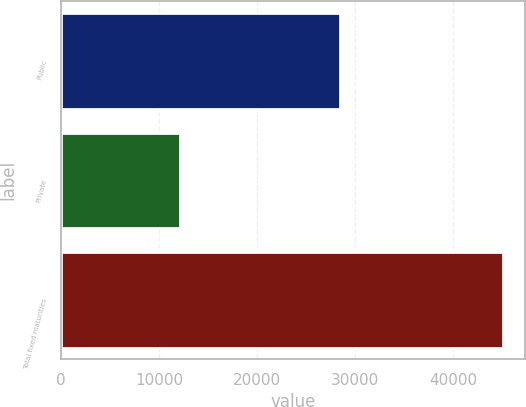Convert chart to OTSL. <chart><loc_0><loc_0><loc_500><loc_500><bar_chart><fcel>Public<fcel>Private<fcel>Total fixed maturities<nl><fcel>28439.8<fcel>12159.7<fcel>45111.8<nl></chart> 